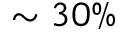<formula> <loc_0><loc_0><loc_500><loc_500>\sim 3 0 \%</formula> 